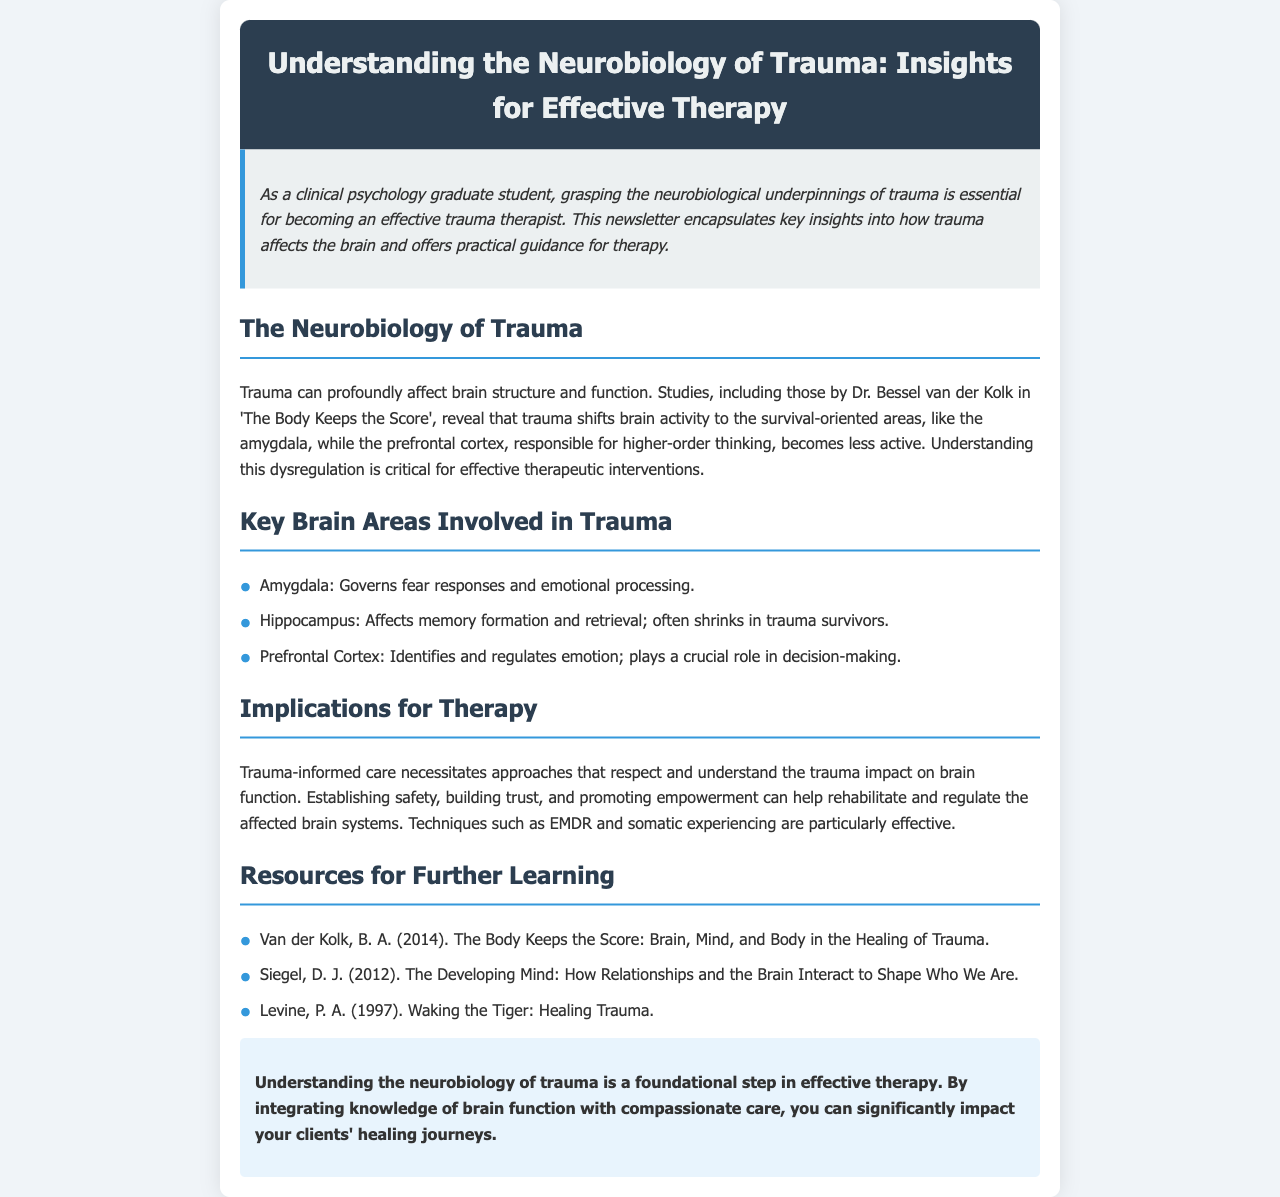What is the title of the newsletter? The title of the newsletter is prominently displayed in the header section of the document.
Answer: Understanding the Neurobiology of Trauma: Insights for Effective Therapy Who is the author mentioned in the document for their work on trauma? Dr. Bessel van der Kolk is cited in the context of trauma studies and is a key figure mentioned in the document.
Answer: Dr. Bessel van der Kolk What is the primary role of the amygdala? The document specifies that the amygdala governs fear responses and emotional processing, providing key information about its function.
Answer: Fear responses and emotional processing Which therapy techniques are highlighted as particularly effective? The document lists EMDR and somatic experiencing as effective therapy techniques for trauma-informed care.
Answer: EMDR and somatic experiencing What does the prefrontal cortex regulate? According to the document, the prefrontal cortex plays a crucial role in identifying and regulating emotion.
Answer: Emotion regulation What is one resource for further learning mentioned? The document provides specific titles and authors for further reading, indicating helpful literature on the subject of trauma.
Answer: The Body Keeps the Score: Brain, Mind, and Body in the Healing of Trauma What are the three key brain areas involved in trauma? The document explicitly lists the amygdala, hippocampus, and prefrontal cortex as the key brain areas affected by trauma.
Answer: Amygdala, hippocampus, prefrontal cortex Why is trauma-informed care necessary? The document explains that trauma-informed care respects and understands the trauma's impact on brain function, emphasizing its importance in therapy.
Answer: Respects and understands trauma's impact on brain function 